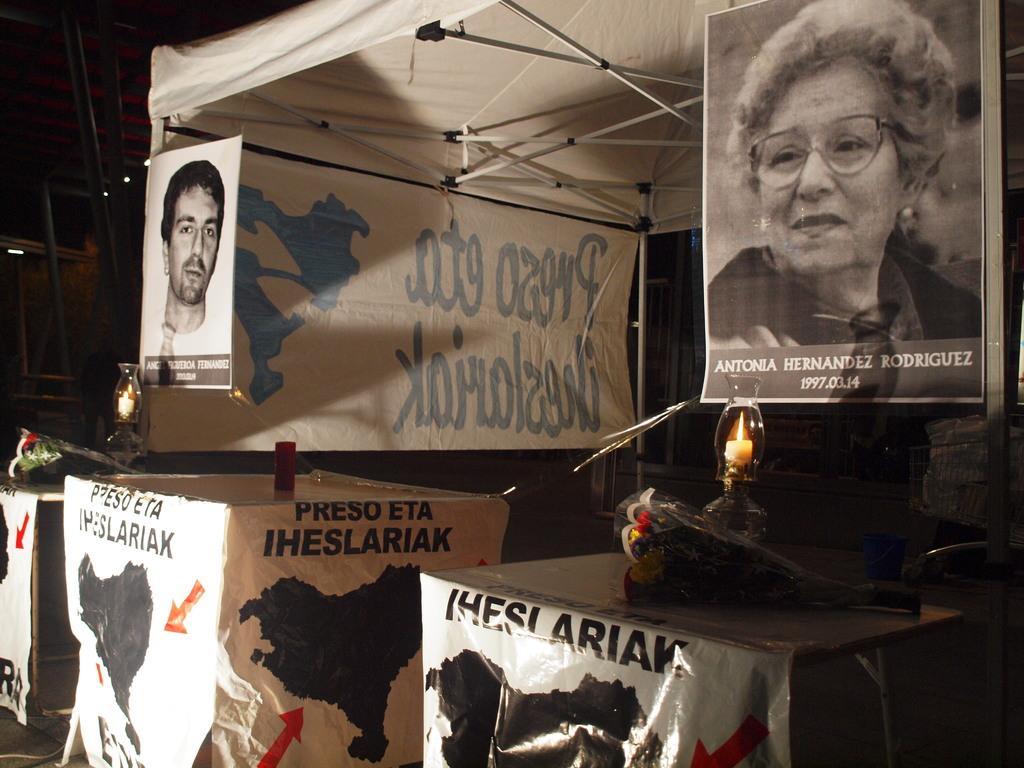Can you describe this image briefly? In this image I can see few posts and in the center of this image I can see two candles. On the top side of this image I can see a tent. 